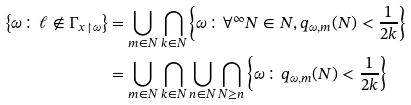<formula> <loc_0><loc_0><loc_500><loc_500>\left \{ \omega \colon \ell \notin \Gamma _ { x \upharpoonright \omega } \right \} & = \bigcup _ { m \in N } \bigcap _ { k \in N } \left \{ \omega \colon \forall ^ { \infty } N \in N , q _ { \omega , m } ( N ) < \frac { 1 } { 2 k } \right \} \\ & = \bigcup _ { m \in N } \bigcap _ { k \in N } \bigcup _ { n \in N } \bigcap _ { N \geq n } \left \{ \omega \colon q _ { \omega , m } ( N ) < \frac { 1 } { 2 k } \right \}</formula> 